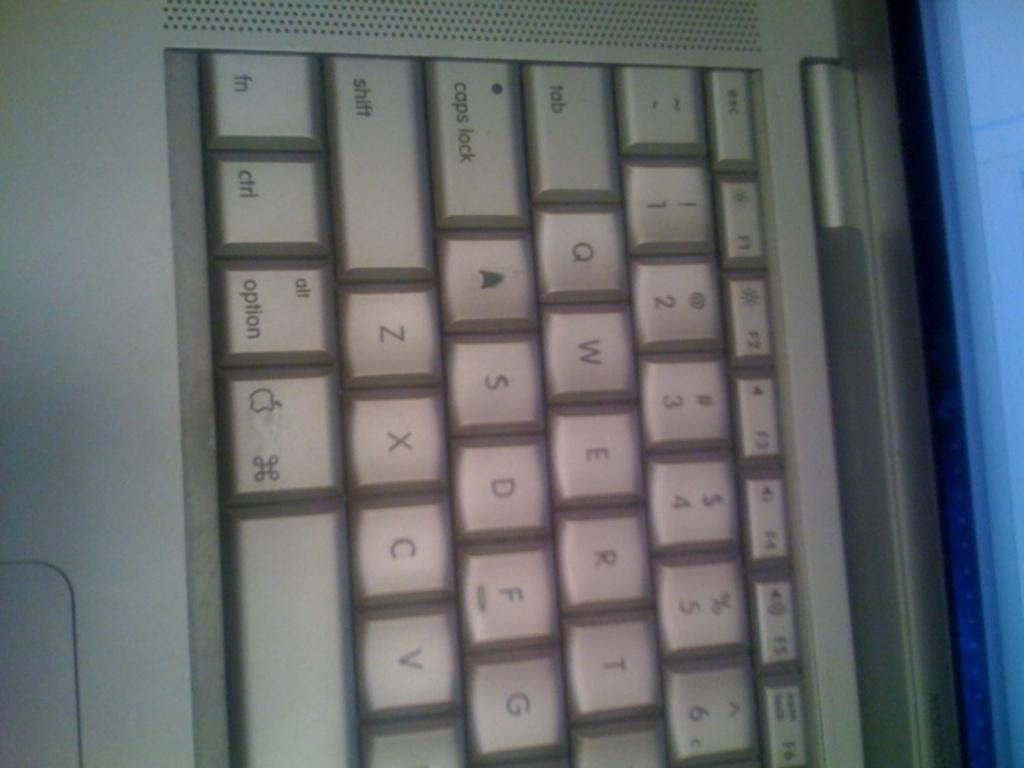<image>
Write a terse but informative summary of the picture. Part of a  keyboard  with the Start and Caps Lock keys at the top of the picture. 